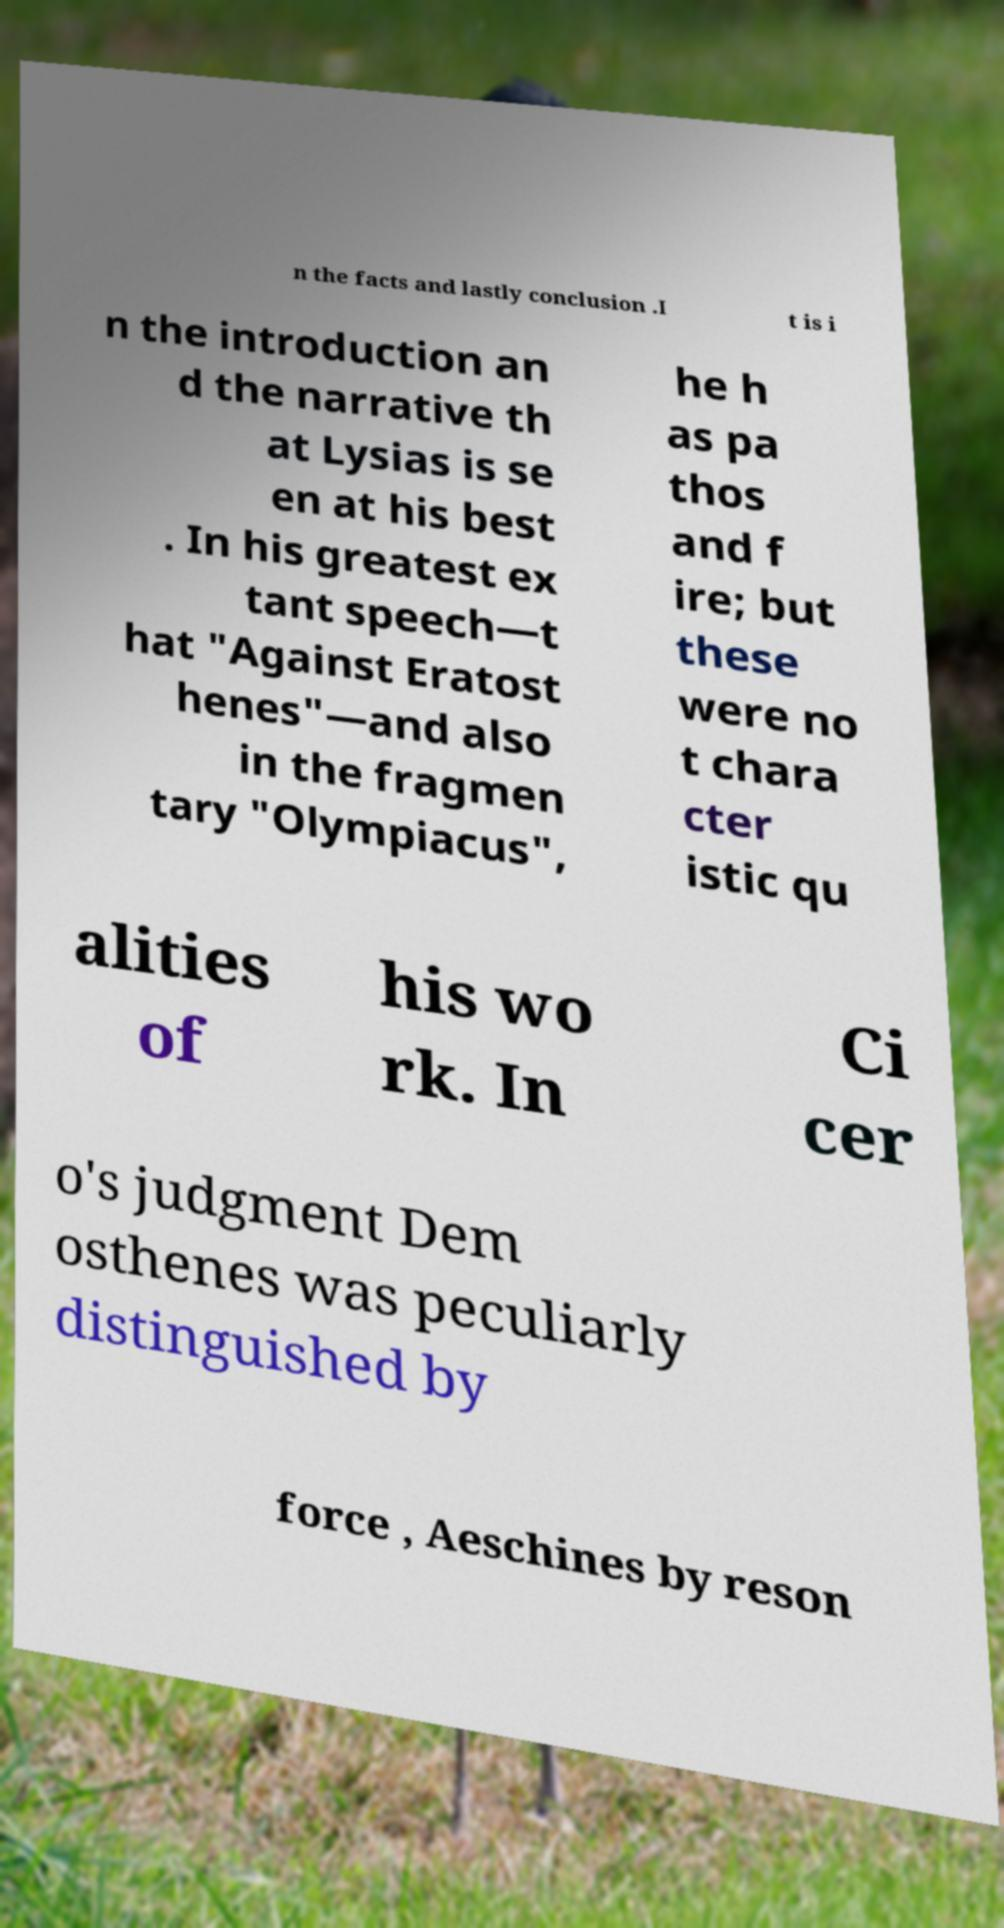Could you extract and type out the text from this image? n the facts and lastly conclusion .I t is i n the introduction an d the narrative th at Lysias is se en at his best . In his greatest ex tant speech—t hat "Against Eratost henes"—and also in the fragmen tary "Olympiacus", he h as pa thos and f ire; but these were no t chara cter istic qu alities of his wo rk. In Ci cer o's judgment Dem osthenes was peculiarly distinguished by force , Aeschines by reson 